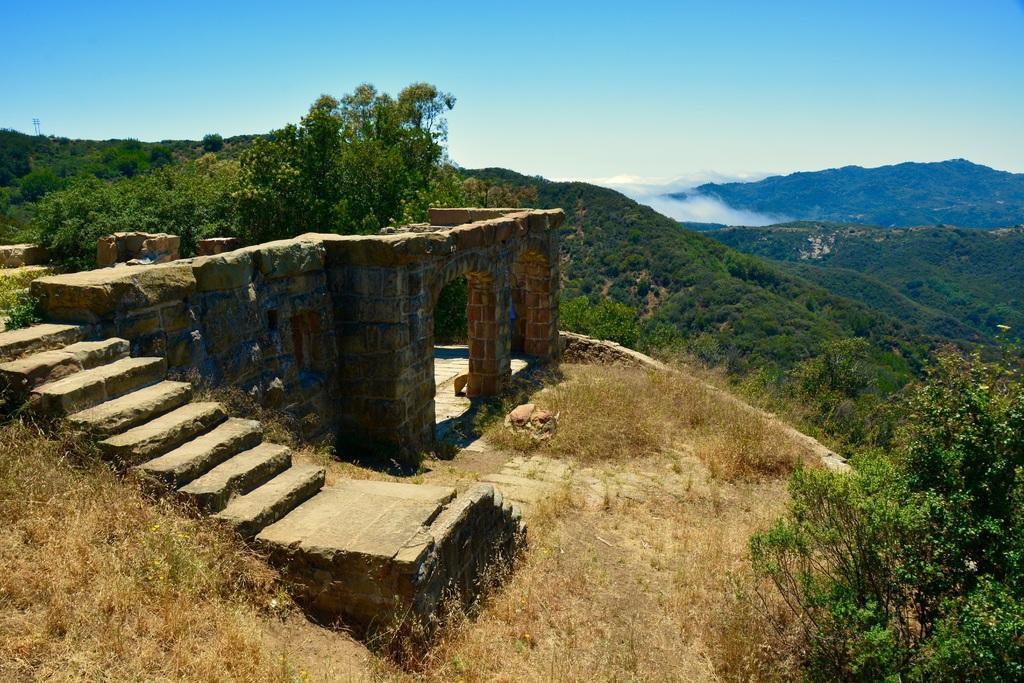Can you describe this image briefly? In this image, we can see the wall and some stairs. We can see some plants, trees, hills and the sky. We can see the ground and some grass. 